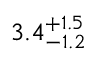<formula> <loc_0><loc_0><loc_500><loc_500>3 . 4 _ { - 1 . 2 } ^ { + 1 . 5 }</formula> 